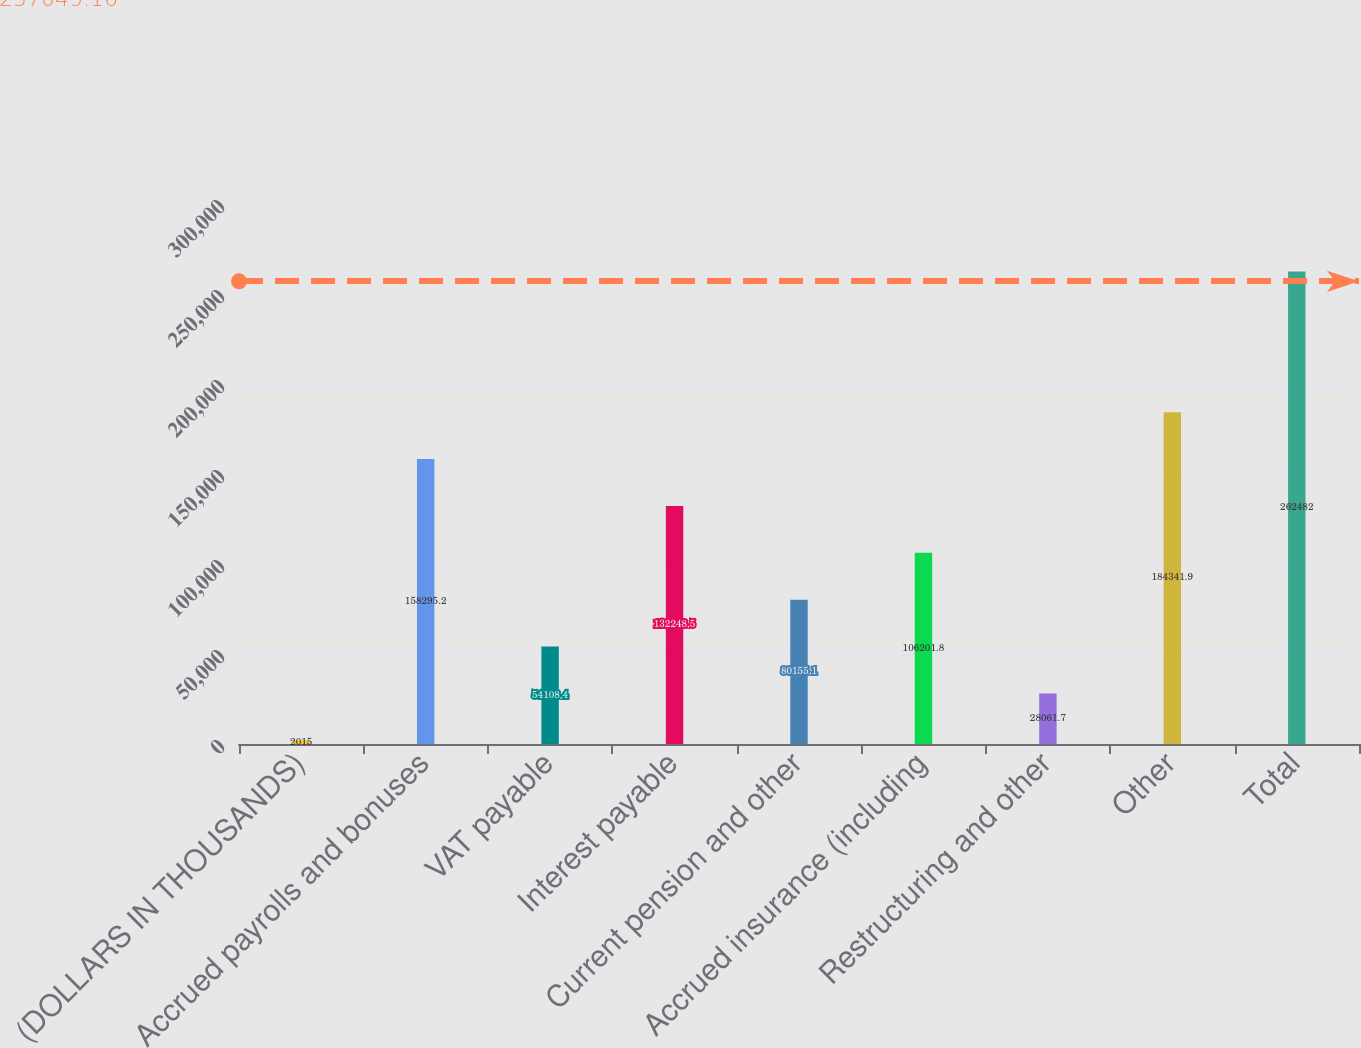Convert chart to OTSL. <chart><loc_0><loc_0><loc_500><loc_500><bar_chart><fcel>(DOLLARS IN THOUSANDS)<fcel>Accrued payrolls and bonuses<fcel>VAT payable<fcel>Interest payable<fcel>Current pension and other<fcel>Accrued insurance (including<fcel>Restructuring and other<fcel>Other<fcel>Total<nl><fcel>2015<fcel>158295<fcel>54108.4<fcel>132248<fcel>80155.1<fcel>106202<fcel>28061.7<fcel>184342<fcel>262482<nl></chart> 